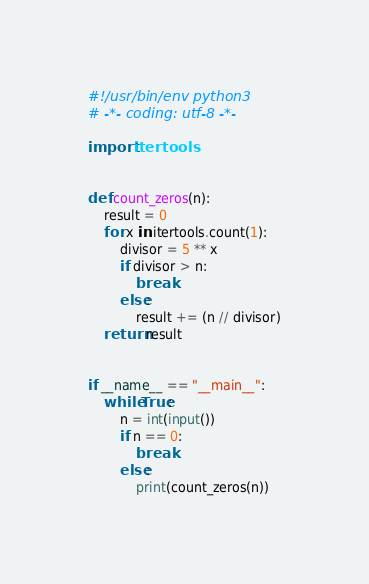<code> <loc_0><loc_0><loc_500><loc_500><_Python_>#!/usr/bin/env python3
# -*- coding: utf-8 -*-

import itertools


def count_zeros(n):
    result = 0
    for x in itertools.count(1):
        divisor = 5 ** x
        if divisor > n:
            break
        else:
            result += (n // divisor)
    return result


if __name__ == "__main__":
    while True:
        n = int(input())
        if n == 0:
            break
        else:
            print(count_zeros(n))</code> 